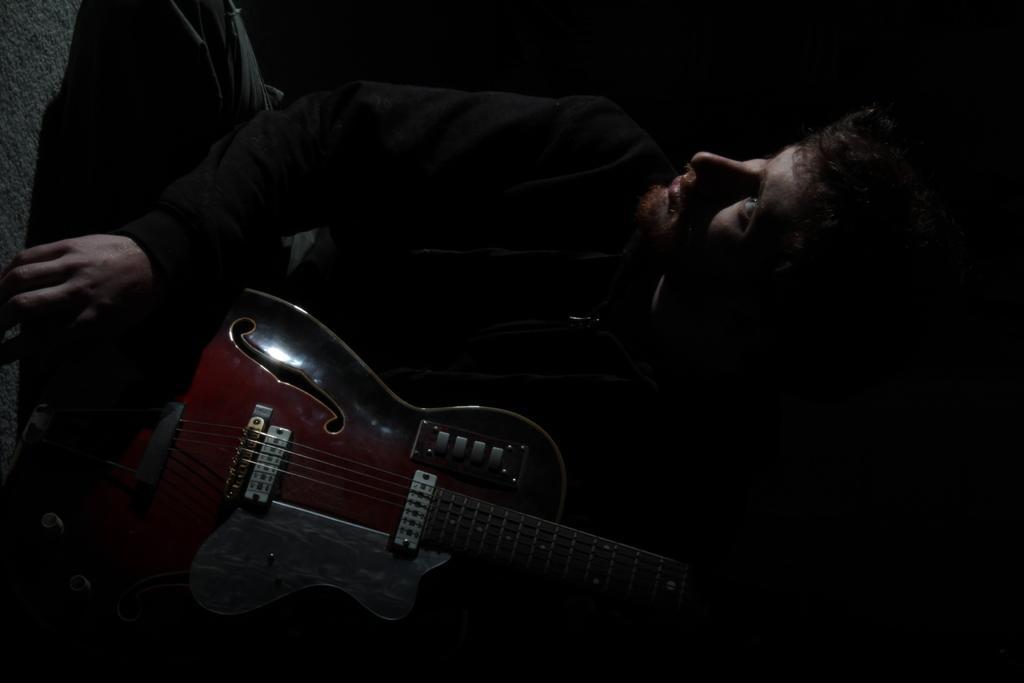In one or two sentences, can you explain what this image depicts? The image consists of a man seated in dark, holding a guitar. 